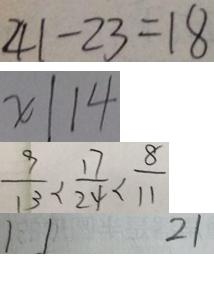<formula> <loc_0><loc_0><loc_500><loc_500>4 1 - 2 3 = 1 8 
 x \vert 1 4 
 \frac { 9 } { 1 3 } < \frac { 1 7 } { 2 4 } < \frac { 8 } { 1 1 } 
 1 1 2 1</formula> 